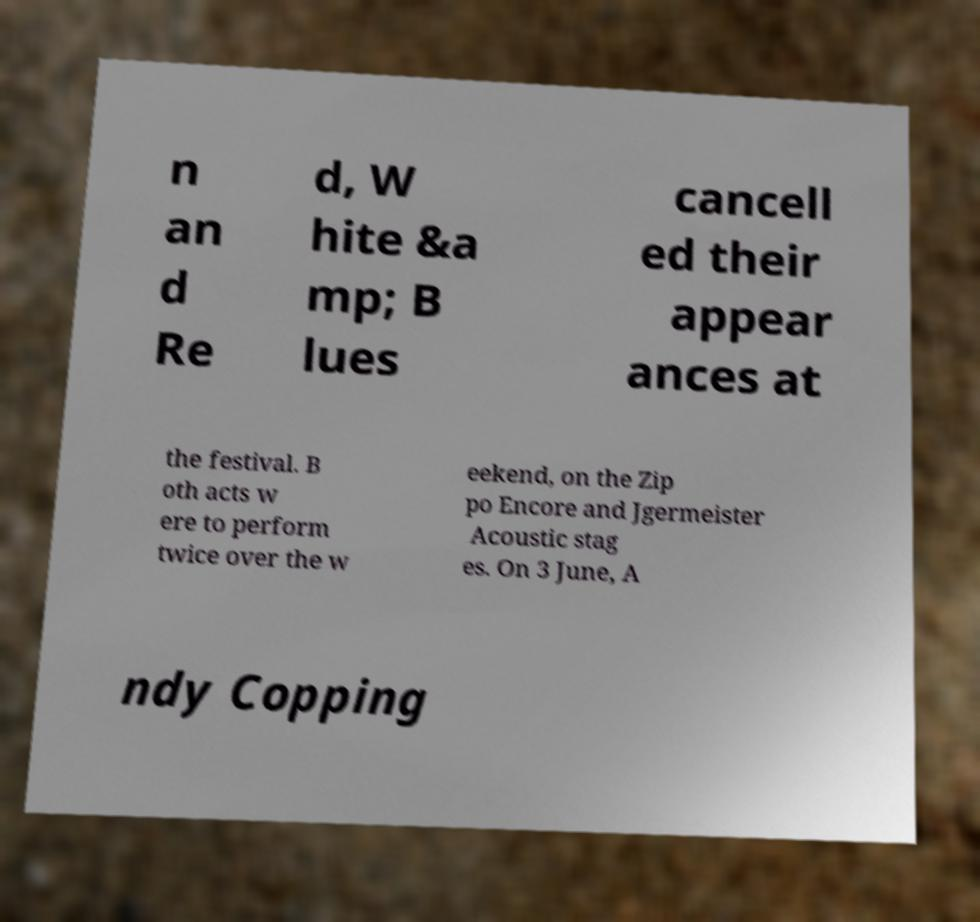Could you assist in decoding the text presented in this image and type it out clearly? n an d Re d, W hite &a mp; B lues cancell ed their appear ances at the festival. B oth acts w ere to perform twice over the w eekend, on the Zip po Encore and Jgermeister Acoustic stag es. On 3 June, A ndy Copping 